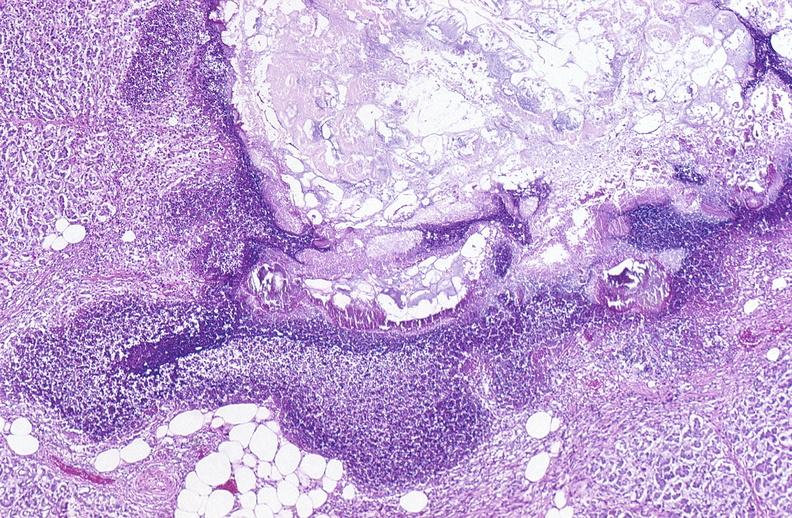does jejunum show pancreatic fat necrosis?
Answer the question using a single word or phrase. No 